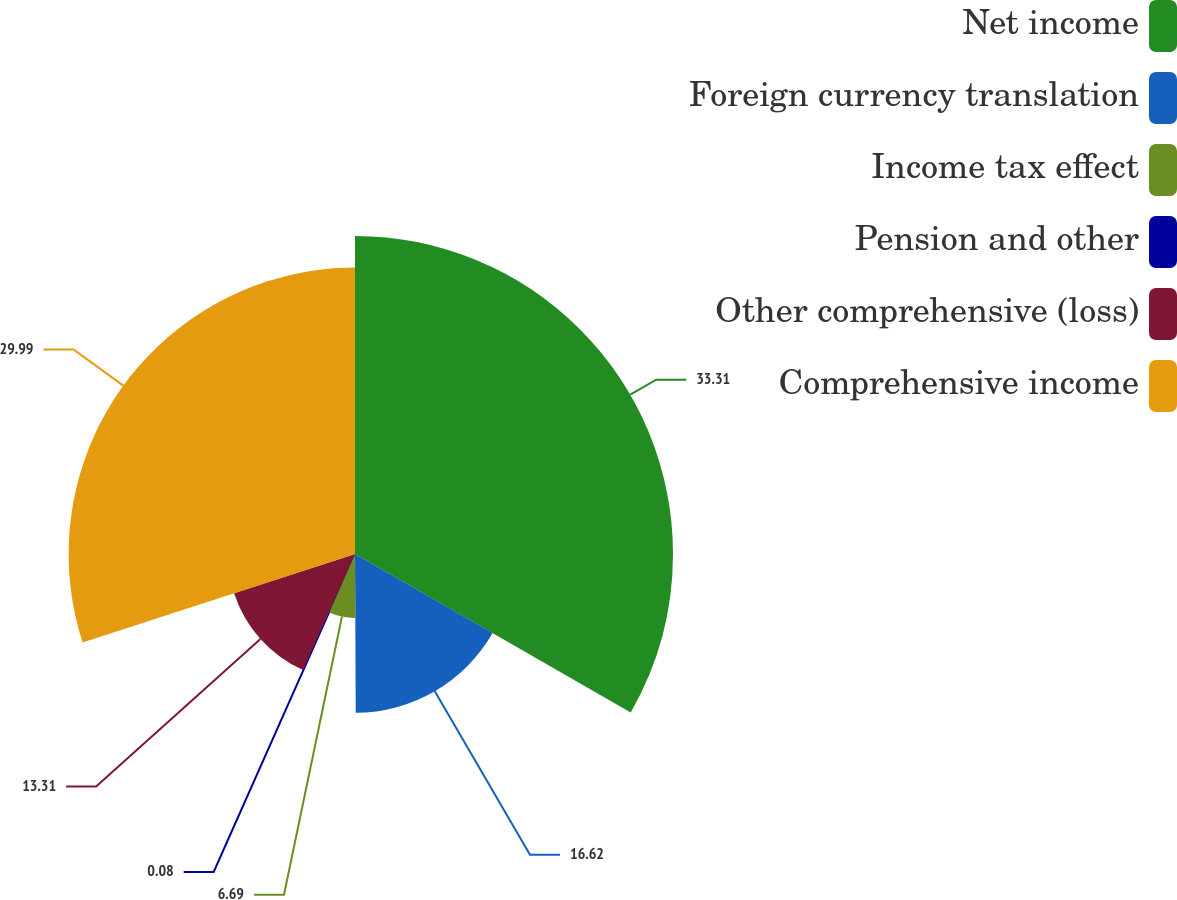Convert chart to OTSL. <chart><loc_0><loc_0><loc_500><loc_500><pie_chart><fcel>Net income<fcel>Foreign currency translation<fcel>Income tax effect<fcel>Pension and other<fcel>Other comprehensive (loss)<fcel>Comprehensive income<nl><fcel>33.3%<fcel>16.62%<fcel>6.69%<fcel>0.08%<fcel>13.31%<fcel>29.99%<nl></chart> 